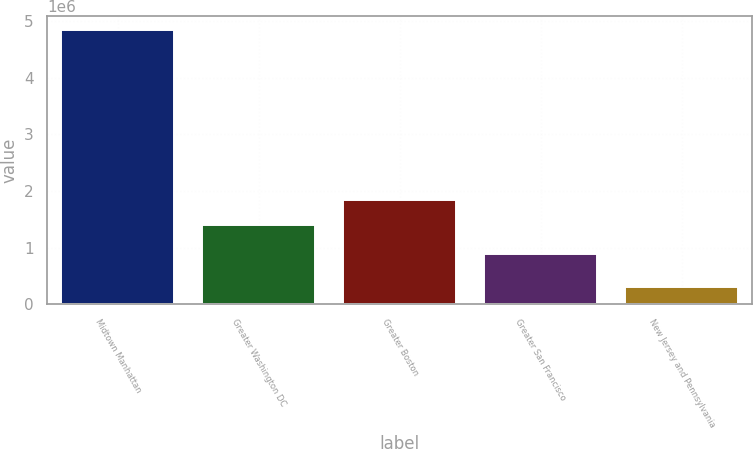<chart> <loc_0><loc_0><loc_500><loc_500><bar_chart><fcel>Midtown Manhattan<fcel>Greater Washington DC<fcel>Greater Boston<fcel>Greater San Francisco<fcel>New Jersey and Pennsylvania<nl><fcel>4.84604e+06<fcel>1.39261e+06<fcel>1.84689e+06<fcel>880795<fcel>303199<nl></chart> 